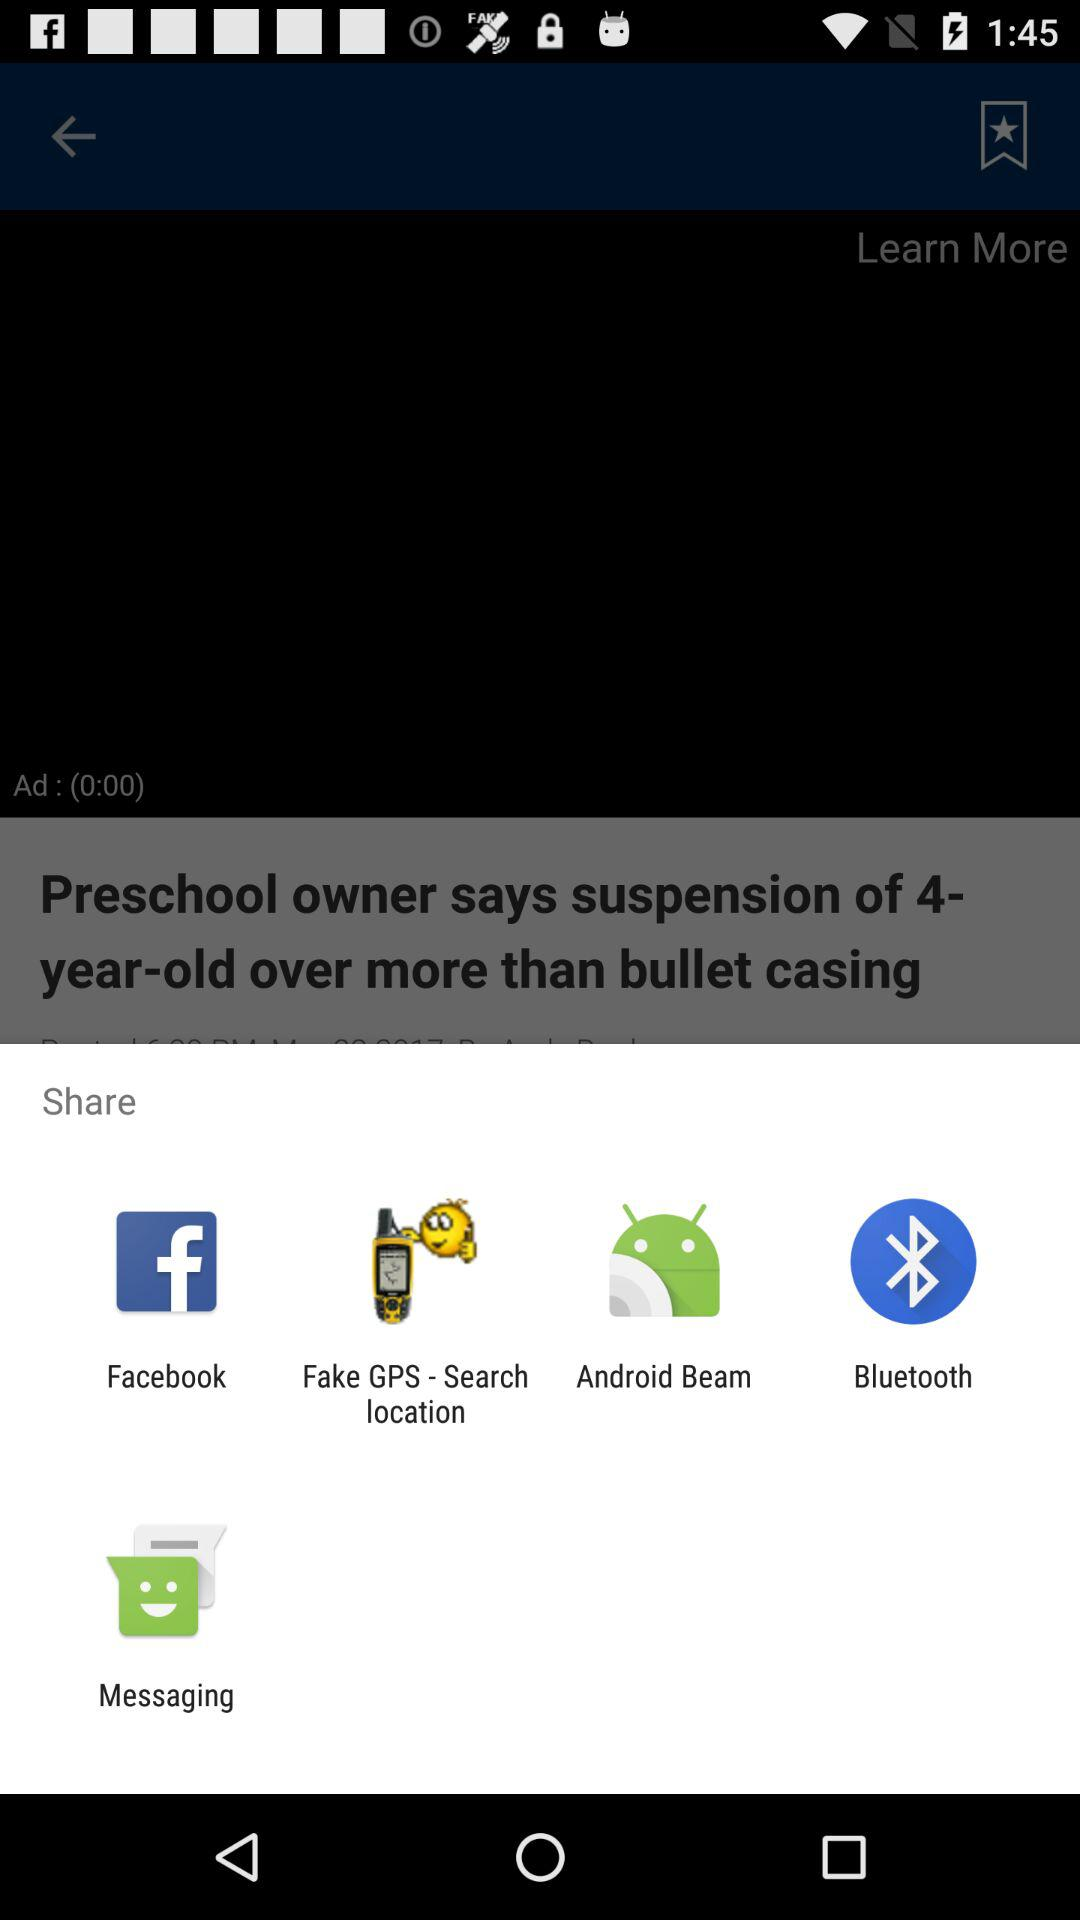Through what applications can the user share the video? The user can share the video using "Facebook", "Fake GPS - Search location", "Android Beam", "Bluetooth", and "Messaging". 